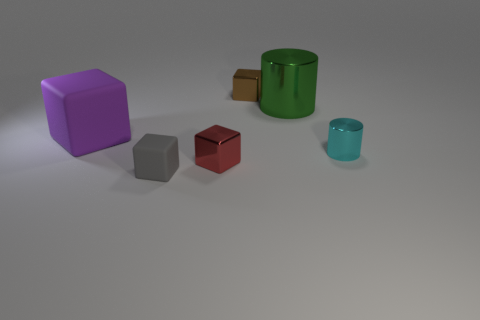There is a tiny gray cube; are there any tiny brown objects in front of it?
Your response must be concise. No. The shiny block that is in front of the large thing to the right of the large thing that is on the left side of the gray rubber object is what color?
Offer a terse response. Red. Do the tiny rubber object and the purple rubber object have the same shape?
Provide a short and direct response. Yes. There is another cylinder that is the same material as the green cylinder; what is its color?
Offer a terse response. Cyan. How many things are either objects that are in front of the large matte cube or small brown objects?
Give a very brief answer. 4. There is a metallic cube that is in front of the purple thing; what is its size?
Offer a very short reply. Small. There is a purple matte cube; is it the same size as the shiny cylinder that is in front of the big matte object?
Provide a short and direct response. No. What color is the metallic cube that is in front of the large thing right of the tiny rubber block?
Keep it short and to the point. Red. What is the size of the green metallic object?
Keep it short and to the point. Large. Are there more tiny metallic objects that are behind the red thing than objects to the left of the large shiny thing?
Provide a succinct answer. No. 